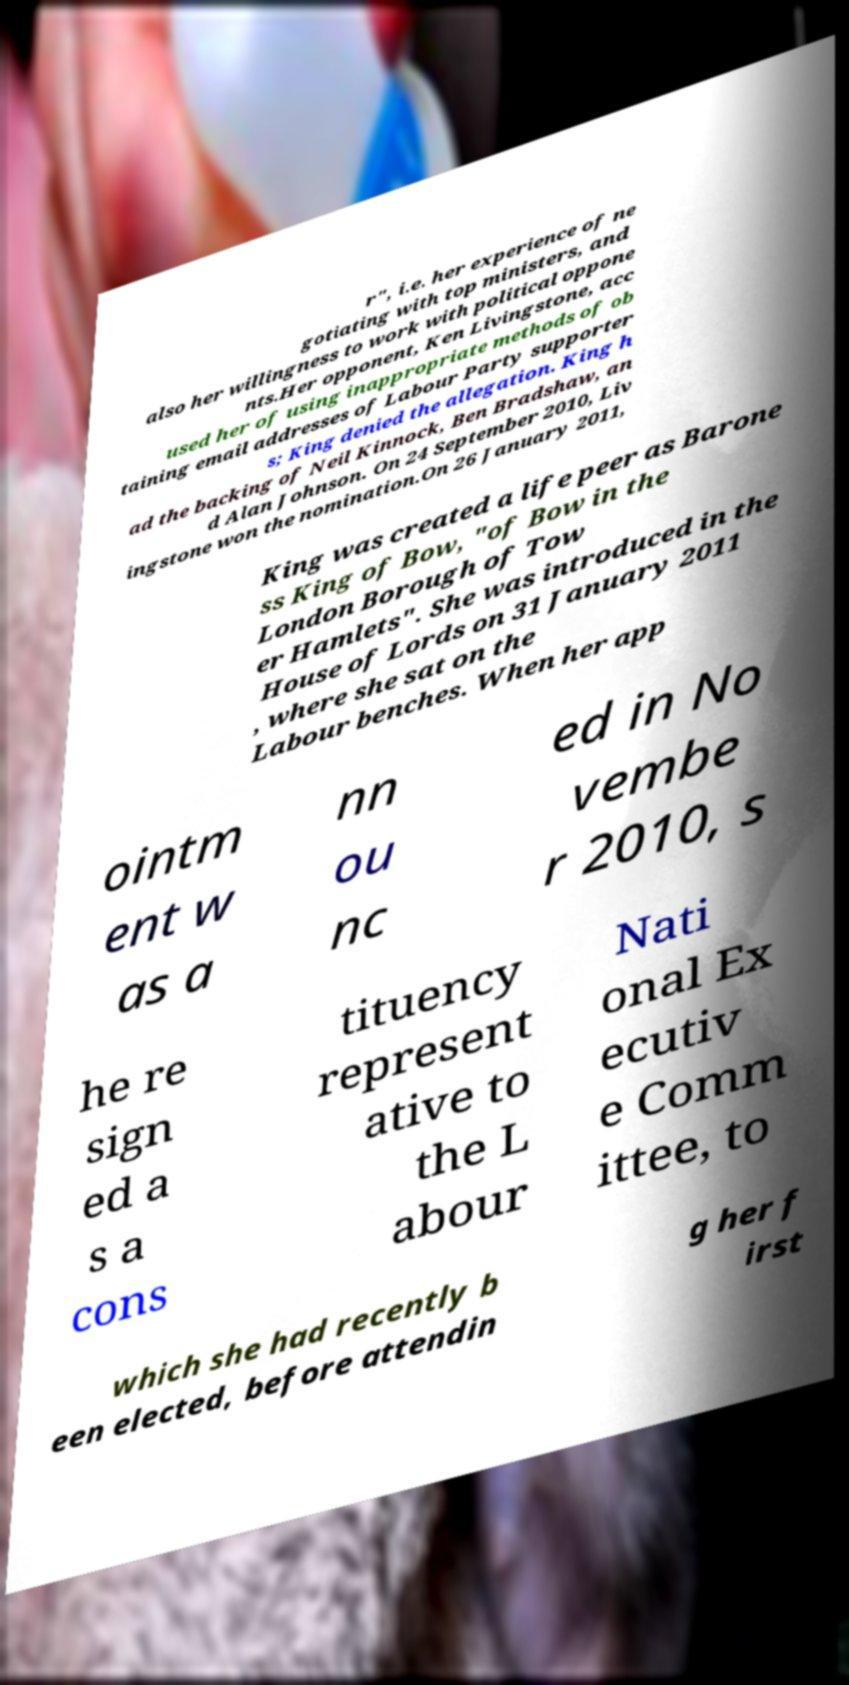Please identify and transcribe the text found in this image. r", i.e. her experience of ne gotiating with top ministers, and also her willingness to work with political oppone nts.Her opponent, Ken Livingstone, acc used her of using inappropriate methods of ob taining email addresses of Labour Party supporter s; King denied the allegation. King h ad the backing of Neil Kinnock, Ben Bradshaw, an d Alan Johnson. On 24 September 2010, Liv ingstone won the nomination.On 26 January 2011, King was created a life peer as Barone ss King of Bow, "of Bow in the London Borough of Tow er Hamlets". She was introduced in the House of Lords on 31 January 2011 , where she sat on the Labour benches. When her app ointm ent w as a nn ou nc ed in No vembe r 2010, s he re sign ed a s a cons tituency represent ative to the L abour Nati onal Ex ecutiv e Comm ittee, to which she had recently b een elected, before attendin g her f irst 